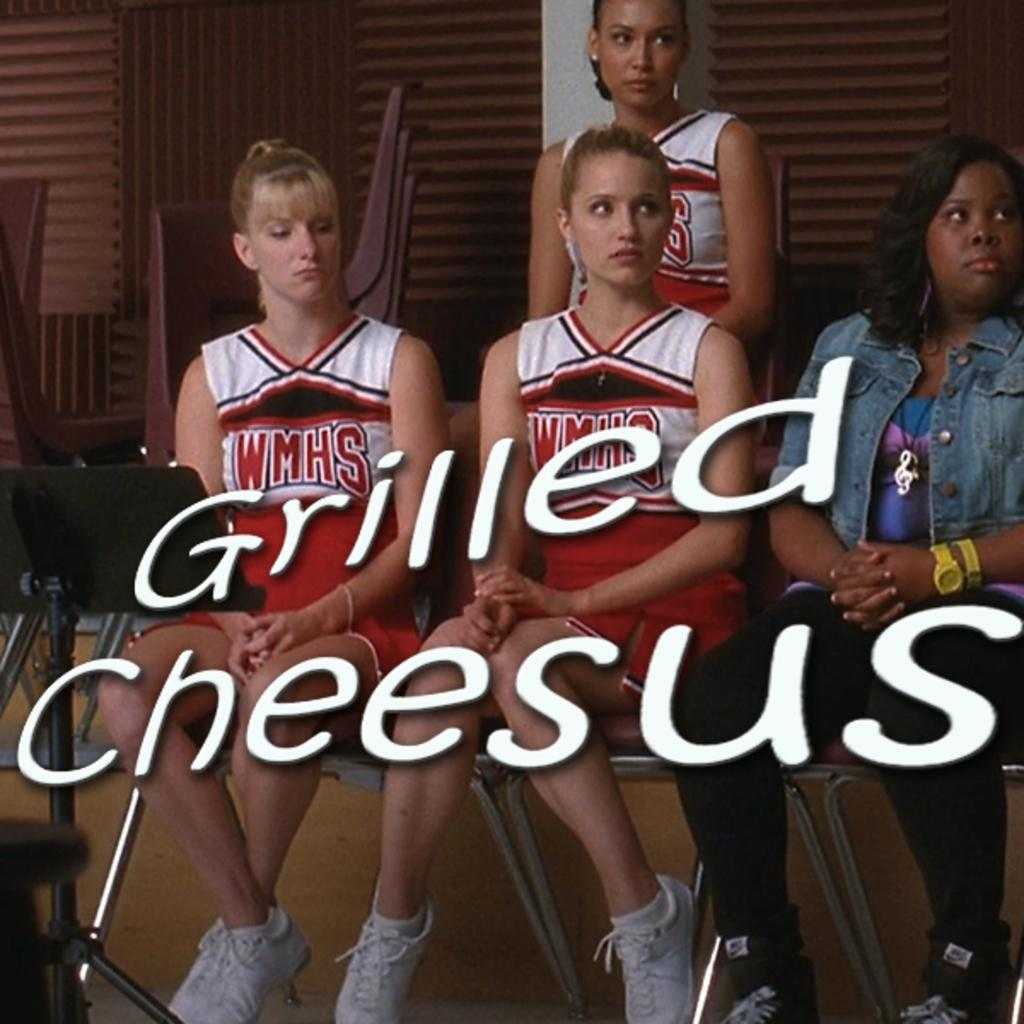Provide a one-sentence caption for the provided image. Several girls are wearing cheerleading outfits reading WMHS while looking at something. 